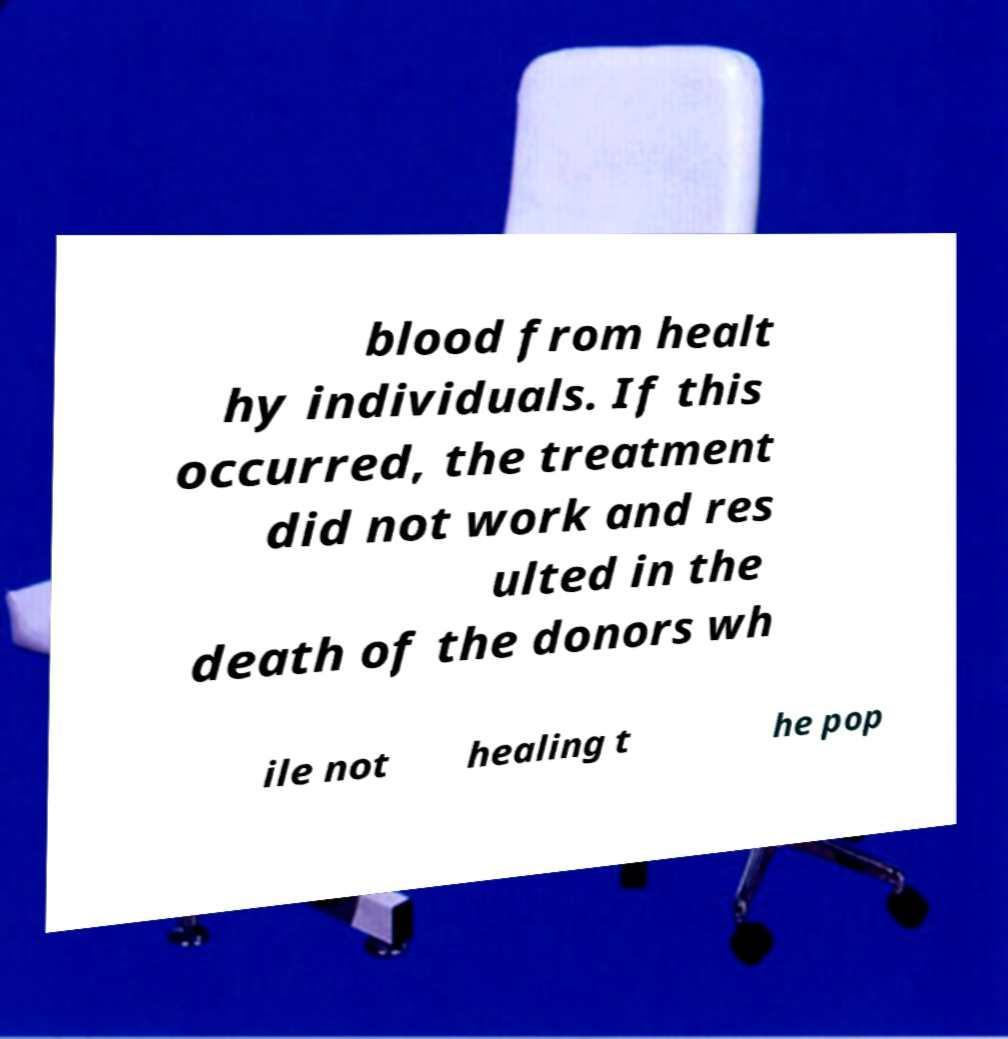Can you read and provide the text displayed in the image?This photo seems to have some interesting text. Can you extract and type it out for me? blood from healt hy individuals. If this occurred, the treatment did not work and res ulted in the death of the donors wh ile not healing t he pop 